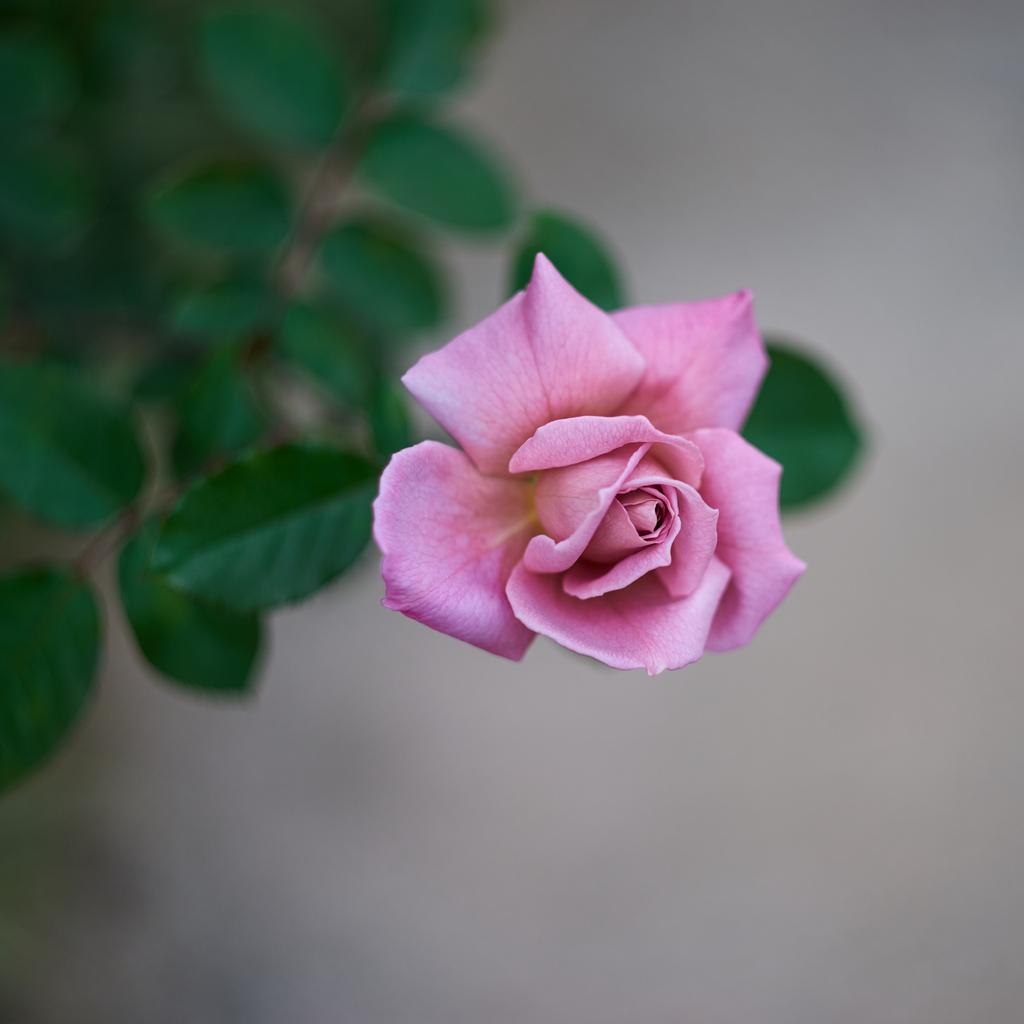What type of flower is in the image? There is a pink color rose in the image. What else can be seen in the image besides the rose? Leaves are visible in the image. Are there any snakes slithering around the rose in the image? No, there are no snakes present in the image. Can you tell me how many bags of popcorn are visible in the image? There is no popcorn present in the image; it only features a pink color rose and leaves. 